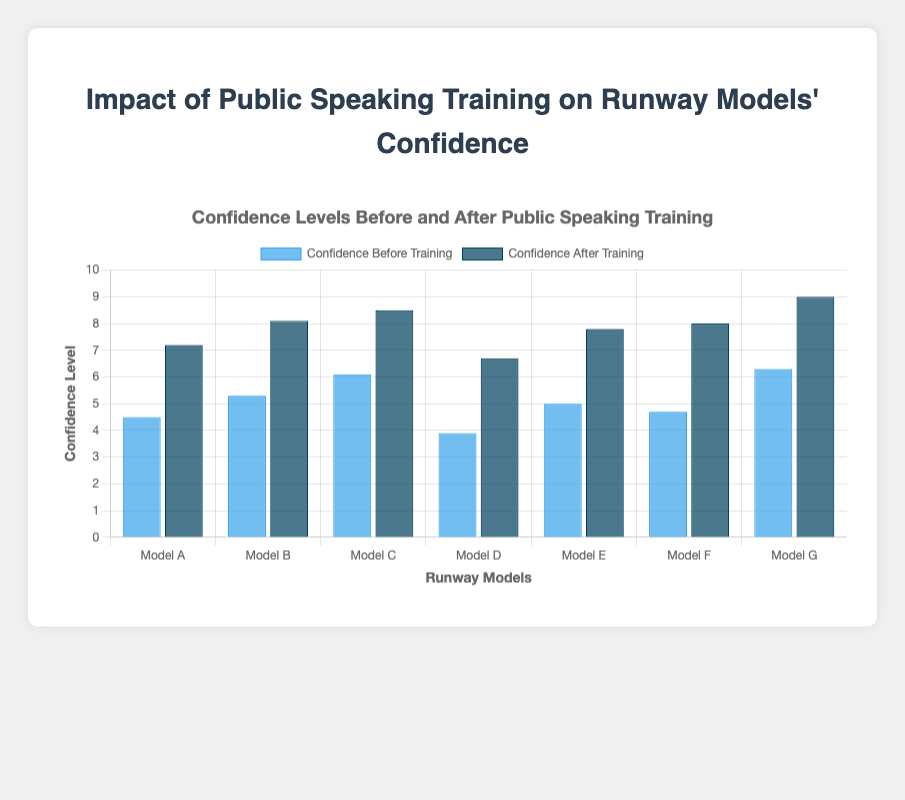What is the average confidence level before training? Add all the confidence levels before training and divide by the number of models: (4.5 + 5.3 + 6.1 + 3.9 + 5.0 + 4.7 + 6.3) / 7 = 35.8 / 7
Answer: 5.11 Which model showed the highest confidence after training? Identify the model with the highest bar in the 'Confidence After Training' group. Model G has the highest bar with a value of 9.0.
Answer: Model G What is the difference in confidence level before and after training for Model D? Subtract the 'Confidence Before Training' value from the 'Confidence After Training' value for Model D: 6.7 - 3.9 = 2.8
Answer: 2.8 How much did Model F's confidence increase after training? Subtract the 'Confidence Before Training' value from the 'Confidence After Training' value for Model F: 8.0 - 4.7 = 3.3
Answer: 3.3 Which models had a confidence level of 5.0 or higher before training? Identify the models with a 'Confidence Before Training' value of 5.0 or greater. Models B, C, E, and G meet this criterion.
Answer: Models B, C, E, G What is the average increase in confidence levels after training for all models? Calculate the increase for each model and then find the average: ((7.2 - 4.5) + (8.1 - 5.3) + (8.5 - 6.1) + (6.7 - 3.9) + (7.8 - 5.0) + (8.0 - 4.7) + (9.0 - 6.3)) / 7 = (2.7 + 2.8 + 2.4 + 2.8 + 2.8 + 3.3 + 2.7) / 7 = 19.5 / 7
Answer: 2.79 Between which two models was the improvement in confidence the smallest? Calculate the difference for all models and find the smallest one: (2.7 for Model A, 2.8 for Model B, 2.4 for Model C, 2.8 for Model D, 2.8 for Model E, 3.3 for Model F, 2.7 for Model G). The smallest difference is Model C (2.4). There is no tie, so the improvement is the smallest for a single model, Model C.
Answer: Model C 